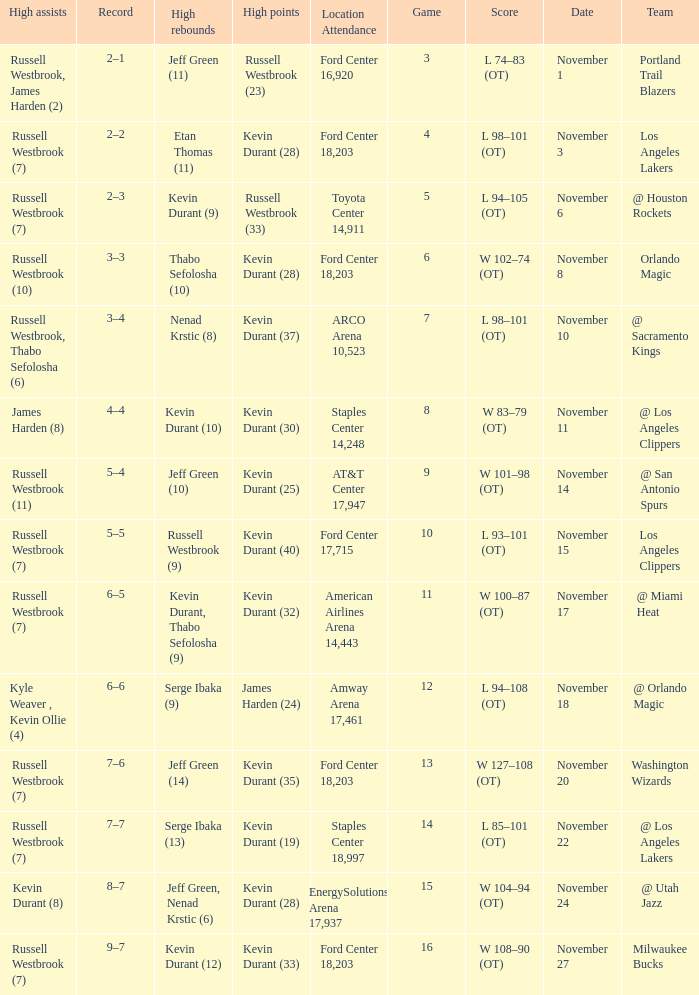What was the record in the game in which Jeff Green (14) did the most high rebounds? 7–6. 